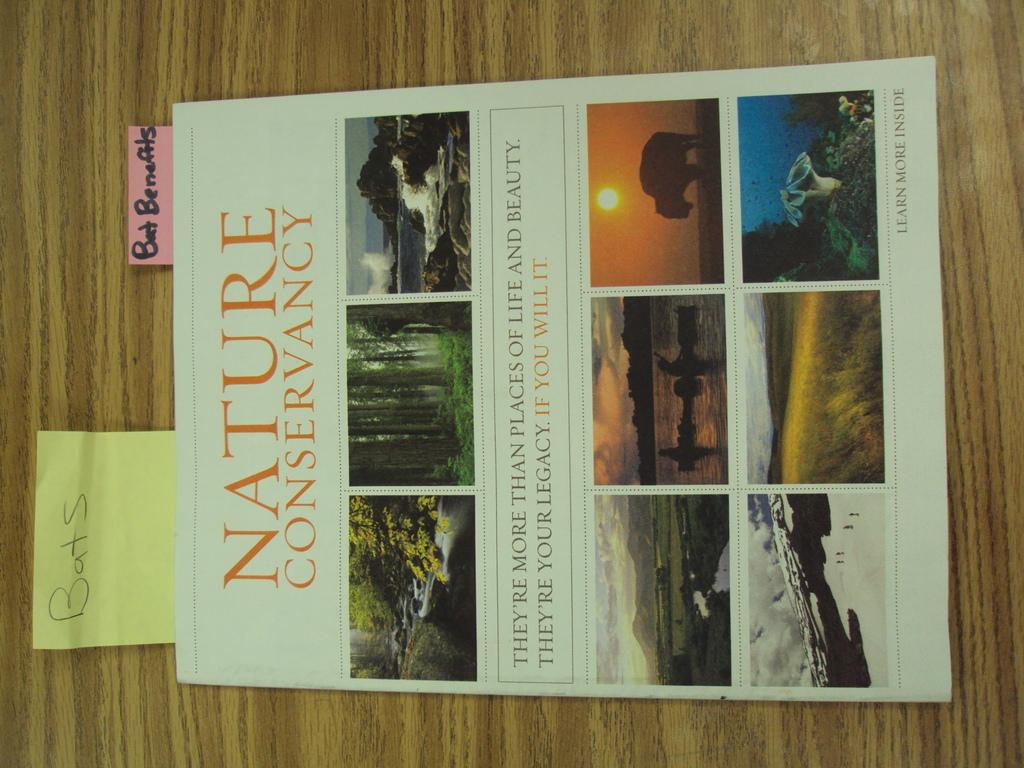What is the title of the book?
Ensure brevity in your answer.  Nature conservancy. 